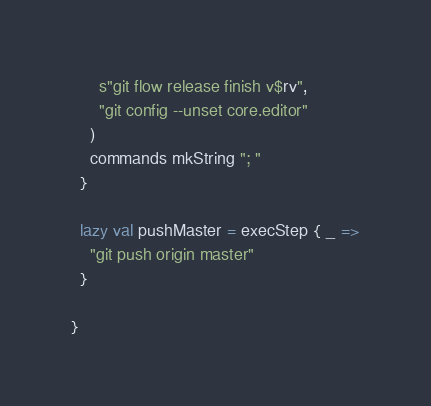Convert code to text. <code><loc_0><loc_0><loc_500><loc_500><_Scala_>      s"git flow release finish v$rv",
      "git config --unset core.editor"
    )
    commands mkString "; "
  }

  lazy val pushMaster = execStep { _ =>
    "git push origin master"
  }

}
</code> 